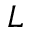Convert formula to latex. <formula><loc_0><loc_0><loc_500><loc_500>L</formula> 